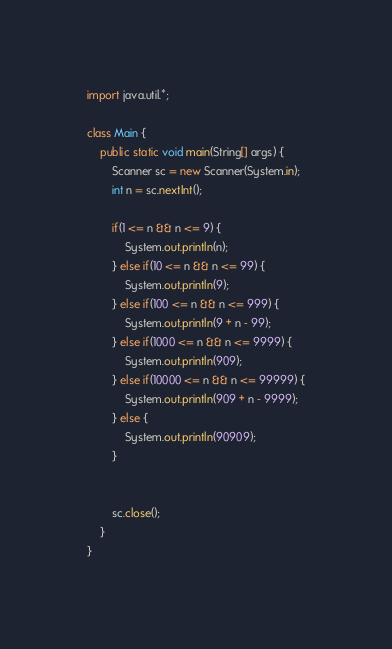<code> <loc_0><loc_0><loc_500><loc_500><_Java_>import java.util.*;
 
class Main {
    public static void main(String[] args) {
        Scanner sc = new Scanner(System.in);
        int n = sc.nextInt();
        
        if(1 <= n && n <= 9) {
        	System.out.println(n);
        } else if(10 <= n && n <= 99) {
        	System.out.println(9);
        } else if(100 <= n && n <= 999) {
        	System.out.println(9 + n - 99);
        } else if(1000 <= n && n <= 9999) {
        	System.out.println(909);
        } else if(10000 <= n && n <= 99999) {
        	System.out.println(909 + n - 9999);
        } else {
        	System.out.println(90909);
        }
        
        
        sc.close();
    }
}
</code> 